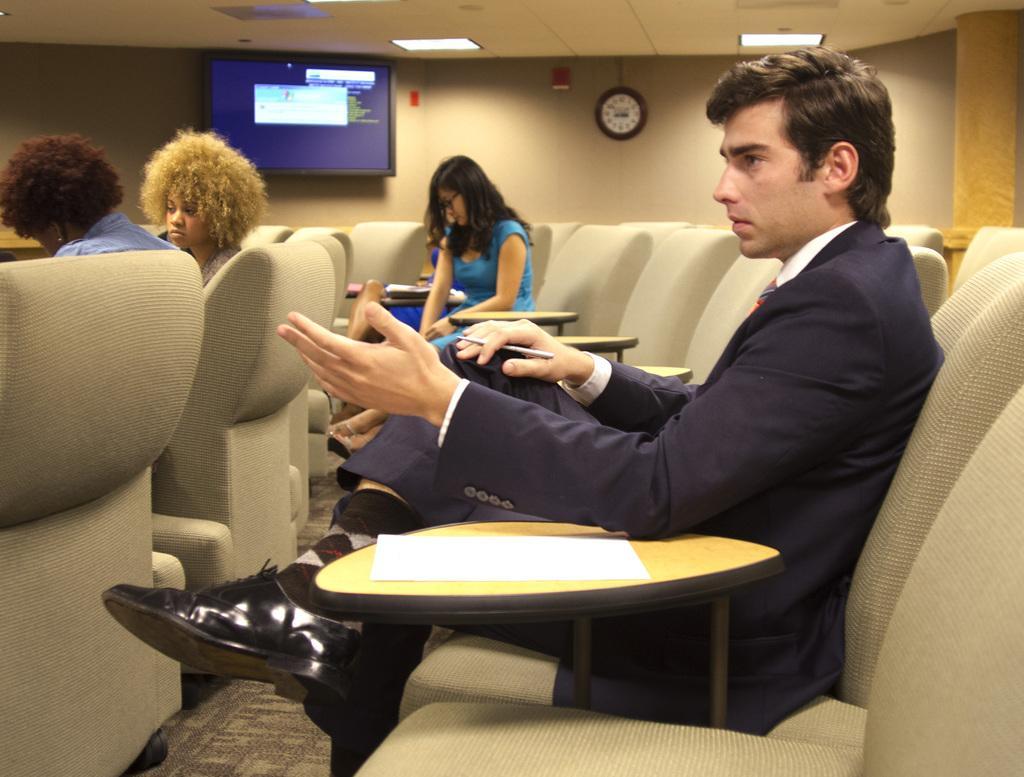Can you describe this image briefly? In this image I see 3 women and a man who are sitting on chairs and I see tables and on this table I see a white paper. In the background I see the wall and I see a TV over here and I see a clock over here and I see the lights on the ceiling. 